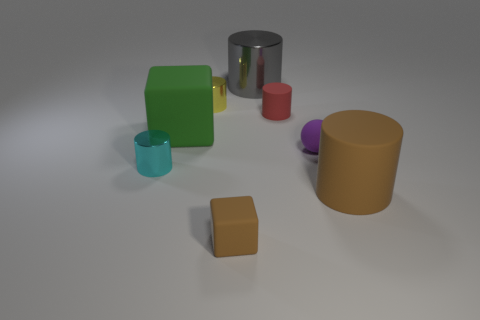How many other objects are the same color as the small block?
Offer a terse response. 1. What number of large things are the same color as the tiny block?
Keep it short and to the point. 1. Does the big rubber cylinder have the same color as the block that is in front of the purple rubber thing?
Your response must be concise. Yes. Are there the same number of shiny cylinders left of the small cyan shiny cylinder and small red matte cylinders that are behind the gray cylinder?
Provide a short and direct response. Yes. There is a big cylinder on the left side of the big brown object; what is its material?
Your answer should be very brief. Metal. What number of things are tiny objects left of the brown cube or rubber balls?
Your response must be concise. 3. What number of other things are the same shape as the large gray shiny object?
Provide a short and direct response. 4. Is the shape of the small metallic thing in front of the small purple rubber thing the same as  the green object?
Keep it short and to the point. No. There is a purple matte sphere; are there any small objects in front of it?
Ensure brevity in your answer.  Yes. What number of small things are either yellow shiny cylinders or green metallic blocks?
Offer a very short reply. 1. 